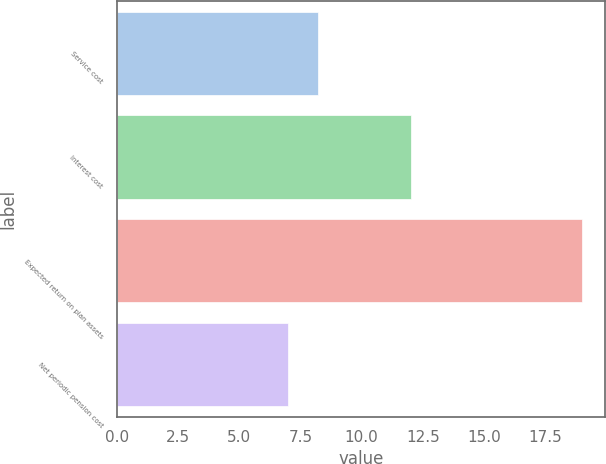Convert chart to OTSL. <chart><loc_0><loc_0><loc_500><loc_500><bar_chart><fcel>Service cost<fcel>Interest cost<fcel>Expected return on plan assets<fcel>Net periodic pension cost<nl><fcel>8.2<fcel>12<fcel>19<fcel>7<nl></chart> 